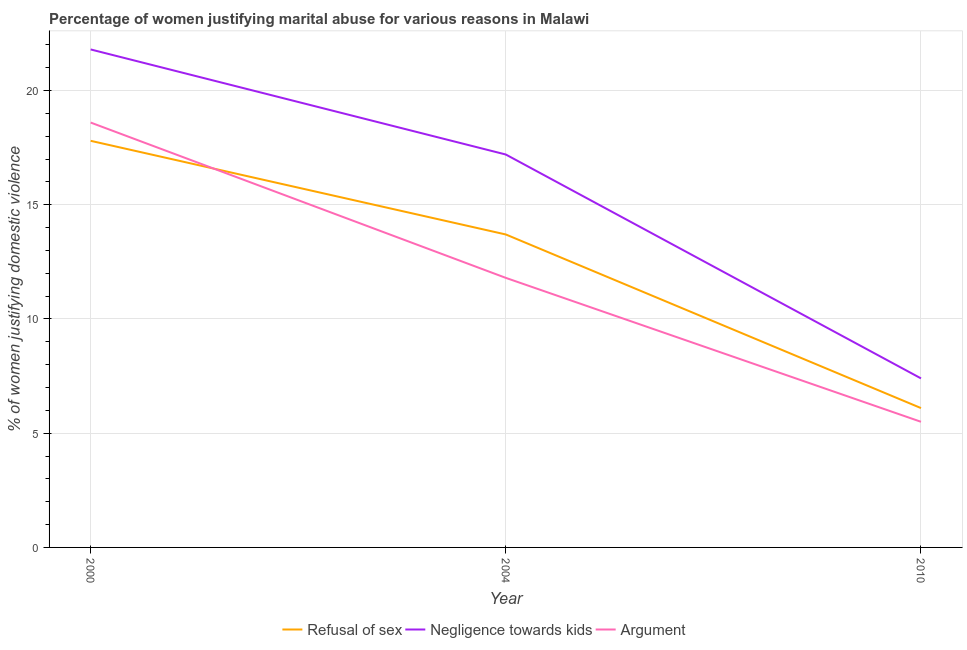How many different coloured lines are there?
Offer a terse response. 3. Does the line corresponding to percentage of women justifying domestic violence due to negligence towards kids intersect with the line corresponding to percentage of women justifying domestic violence due to refusal of sex?
Ensure brevity in your answer.  No. Is the number of lines equal to the number of legend labels?
Offer a very short reply. Yes. What is the percentage of women justifying domestic violence due to refusal of sex in 2010?
Make the answer very short. 6.1. Across all years, what is the maximum percentage of women justifying domestic violence due to refusal of sex?
Your answer should be compact. 17.8. In which year was the percentage of women justifying domestic violence due to arguments maximum?
Keep it short and to the point. 2000. In which year was the percentage of women justifying domestic violence due to refusal of sex minimum?
Your answer should be compact. 2010. What is the total percentage of women justifying domestic violence due to refusal of sex in the graph?
Give a very brief answer. 37.6. What is the difference between the percentage of women justifying domestic violence due to refusal of sex in 2000 and that in 2004?
Keep it short and to the point. 4.1. What is the difference between the percentage of women justifying domestic violence due to negligence towards kids in 2004 and the percentage of women justifying domestic violence due to refusal of sex in 2000?
Offer a very short reply. -0.6. What is the average percentage of women justifying domestic violence due to arguments per year?
Make the answer very short. 11.97. In the year 2000, what is the difference between the percentage of women justifying domestic violence due to arguments and percentage of women justifying domestic violence due to refusal of sex?
Your answer should be very brief. 0.8. What is the ratio of the percentage of women justifying domestic violence due to negligence towards kids in 2000 to that in 2004?
Give a very brief answer. 1.27. Is the percentage of women justifying domestic violence due to negligence towards kids in 2000 less than that in 2010?
Keep it short and to the point. No. Is the difference between the percentage of women justifying domestic violence due to negligence towards kids in 2004 and 2010 greater than the difference between the percentage of women justifying domestic violence due to arguments in 2004 and 2010?
Provide a succinct answer. Yes. What is the difference between the highest and the second highest percentage of women justifying domestic violence due to negligence towards kids?
Ensure brevity in your answer.  4.6. Is it the case that in every year, the sum of the percentage of women justifying domestic violence due to refusal of sex and percentage of women justifying domestic violence due to negligence towards kids is greater than the percentage of women justifying domestic violence due to arguments?
Your answer should be compact. Yes. Is the percentage of women justifying domestic violence due to refusal of sex strictly less than the percentage of women justifying domestic violence due to negligence towards kids over the years?
Your answer should be compact. Yes. What is the difference between two consecutive major ticks on the Y-axis?
Your response must be concise. 5. Does the graph contain grids?
Give a very brief answer. Yes. How are the legend labels stacked?
Offer a very short reply. Horizontal. What is the title of the graph?
Offer a terse response. Percentage of women justifying marital abuse for various reasons in Malawi. Does "Liquid fuel" appear as one of the legend labels in the graph?
Your answer should be compact. No. What is the label or title of the Y-axis?
Your answer should be very brief. % of women justifying domestic violence. What is the % of women justifying domestic violence in Negligence towards kids in 2000?
Make the answer very short. 21.8. What is the % of women justifying domestic violence in Refusal of sex in 2010?
Provide a short and direct response. 6.1. What is the % of women justifying domestic violence of Negligence towards kids in 2010?
Provide a short and direct response. 7.4. What is the % of women justifying domestic violence in Argument in 2010?
Your answer should be very brief. 5.5. Across all years, what is the maximum % of women justifying domestic violence of Negligence towards kids?
Keep it short and to the point. 21.8. Across all years, what is the minimum % of women justifying domestic violence in Refusal of sex?
Make the answer very short. 6.1. Across all years, what is the minimum % of women justifying domestic violence in Negligence towards kids?
Give a very brief answer. 7.4. What is the total % of women justifying domestic violence in Refusal of sex in the graph?
Offer a very short reply. 37.6. What is the total % of women justifying domestic violence of Negligence towards kids in the graph?
Provide a short and direct response. 46.4. What is the total % of women justifying domestic violence in Argument in the graph?
Give a very brief answer. 35.9. What is the difference between the % of women justifying domestic violence of Refusal of sex in 2000 and that in 2004?
Offer a very short reply. 4.1. What is the difference between the % of women justifying domestic violence of Refusal of sex in 2000 and that in 2010?
Provide a succinct answer. 11.7. What is the difference between the % of women justifying domestic violence of Refusal of sex in 2004 and that in 2010?
Make the answer very short. 7.6. What is the difference between the % of women justifying domestic violence of Negligence towards kids in 2004 and that in 2010?
Offer a terse response. 9.8. What is the difference between the % of women justifying domestic violence in Refusal of sex in 2000 and the % of women justifying domestic violence in Argument in 2004?
Your answer should be compact. 6. What is the difference between the % of women justifying domestic violence of Negligence towards kids in 2000 and the % of women justifying domestic violence of Argument in 2004?
Offer a very short reply. 10. What is the difference between the % of women justifying domestic violence in Refusal of sex in 2000 and the % of women justifying domestic violence in Argument in 2010?
Your response must be concise. 12.3. What is the difference between the % of women justifying domestic violence of Refusal of sex in 2004 and the % of women justifying domestic violence of Negligence towards kids in 2010?
Offer a very short reply. 6.3. What is the average % of women justifying domestic violence of Refusal of sex per year?
Provide a short and direct response. 12.53. What is the average % of women justifying domestic violence in Negligence towards kids per year?
Your answer should be very brief. 15.47. What is the average % of women justifying domestic violence in Argument per year?
Provide a short and direct response. 11.97. In the year 2004, what is the difference between the % of women justifying domestic violence of Refusal of sex and % of women justifying domestic violence of Negligence towards kids?
Your response must be concise. -3.5. In the year 2004, what is the difference between the % of women justifying domestic violence in Negligence towards kids and % of women justifying domestic violence in Argument?
Provide a succinct answer. 5.4. In the year 2010, what is the difference between the % of women justifying domestic violence in Refusal of sex and % of women justifying domestic violence in Argument?
Your response must be concise. 0.6. What is the ratio of the % of women justifying domestic violence in Refusal of sex in 2000 to that in 2004?
Ensure brevity in your answer.  1.3. What is the ratio of the % of women justifying domestic violence in Negligence towards kids in 2000 to that in 2004?
Give a very brief answer. 1.27. What is the ratio of the % of women justifying domestic violence in Argument in 2000 to that in 2004?
Make the answer very short. 1.58. What is the ratio of the % of women justifying domestic violence of Refusal of sex in 2000 to that in 2010?
Your answer should be very brief. 2.92. What is the ratio of the % of women justifying domestic violence of Negligence towards kids in 2000 to that in 2010?
Provide a short and direct response. 2.95. What is the ratio of the % of women justifying domestic violence of Argument in 2000 to that in 2010?
Give a very brief answer. 3.38. What is the ratio of the % of women justifying domestic violence of Refusal of sex in 2004 to that in 2010?
Keep it short and to the point. 2.25. What is the ratio of the % of women justifying domestic violence in Negligence towards kids in 2004 to that in 2010?
Offer a terse response. 2.32. What is the ratio of the % of women justifying domestic violence of Argument in 2004 to that in 2010?
Keep it short and to the point. 2.15. 